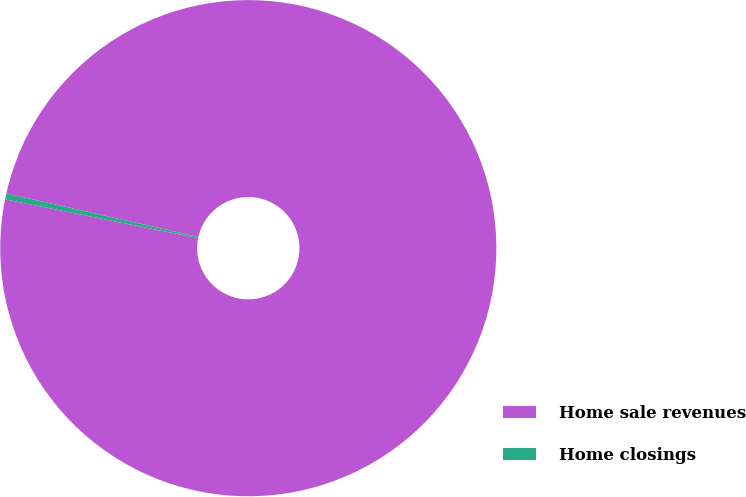Convert chart. <chart><loc_0><loc_0><loc_500><loc_500><pie_chart><fcel>Home sale revenues<fcel>Home closings<nl><fcel>99.61%<fcel>0.39%<nl></chart> 